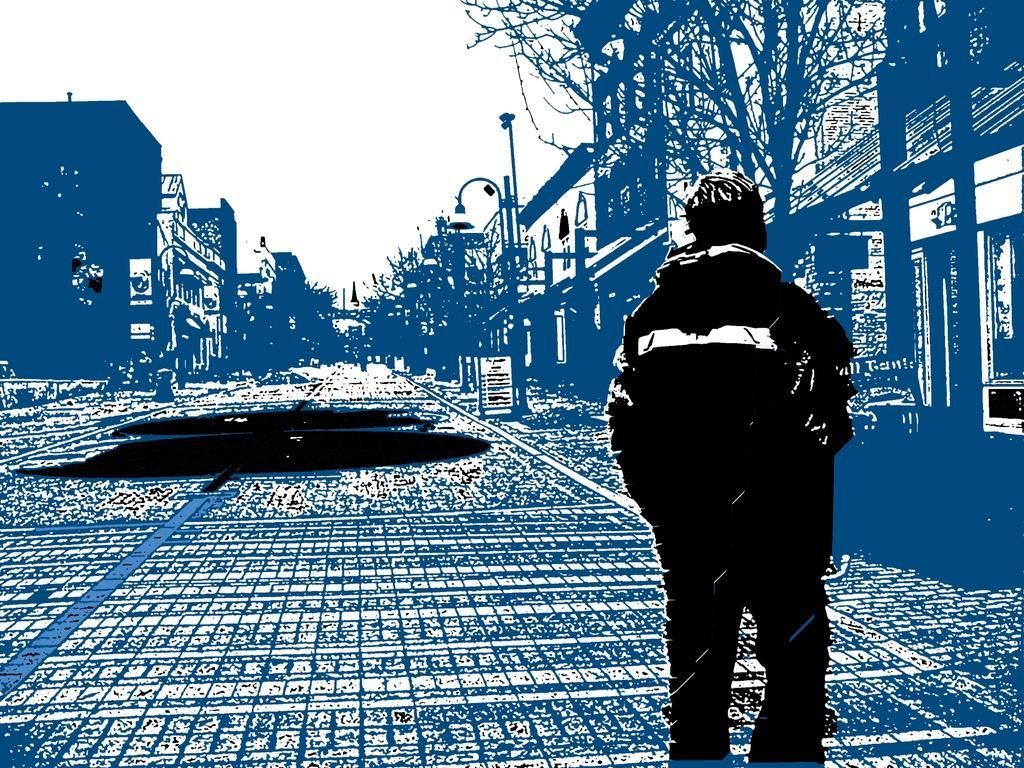Please provide a concise description of this image. This is graphics image. In this image there is a person. On the sides there are buildings and trees. There is a light pole. In the background there is sky. 